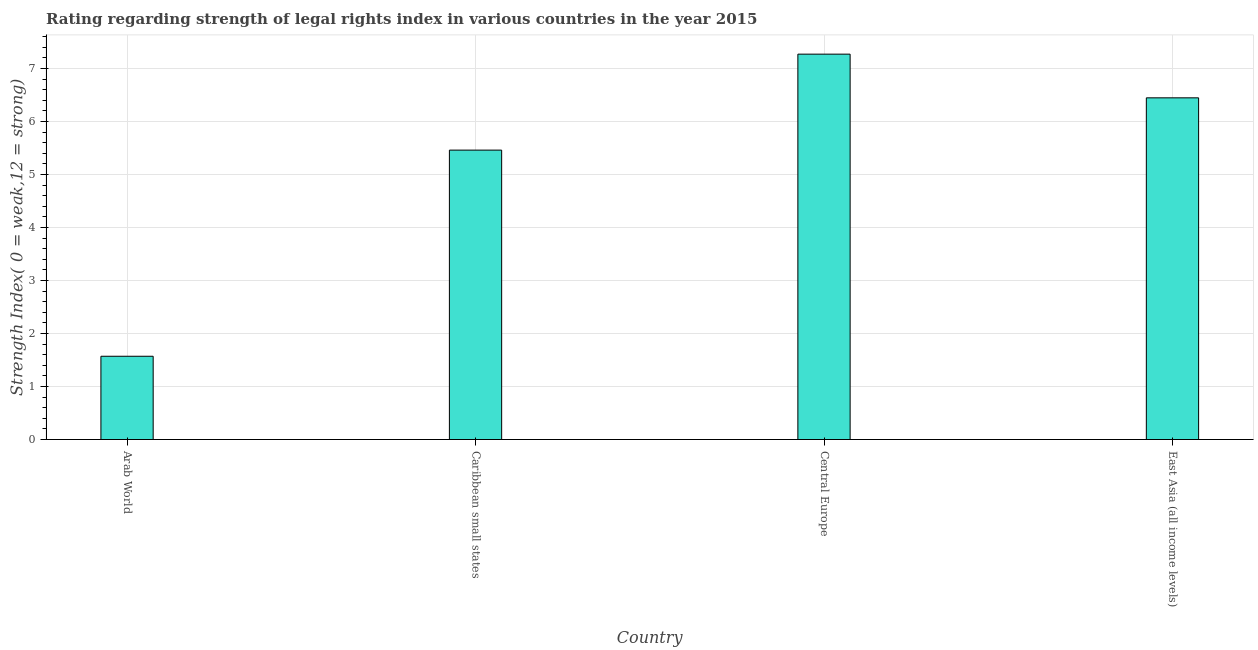Does the graph contain grids?
Your response must be concise. Yes. What is the title of the graph?
Your answer should be very brief. Rating regarding strength of legal rights index in various countries in the year 2015. What is the label or title of the X-axis?
Your answer should be compact. Country. What is the label or title of the Y-axis?
Give a very brief answer. Strength Index( 0 = weak,12 = strong). What is the strength of legal rights index in Caribbean small states?
Your response must be concise. 5.46. Across all countries, what is the maximum strength of legal rights index?
Your answer should be very brief. 7.27. Across all countries, what is the minimum strength of legal rights index?
Your answer should be compact. 1.57. In which country was the strength of legal rights index maximum?
Your answer should be compact. Central Europe. In which country was the strength of legal rights index minimum?
Provide a succinct answer. Arab World. What is the sum of the strength of legal rights index?
Your answer should be compact. 20.75. What is the difference between the strength of legal rights index in Caribbean small states and East Asia (all income levels)?
Offer a very short reply. -0.99. What is the average strength of legal rights index per country?
Your answer should be very brief. 5.19. What is the median strength of legal rights index?
Ensure brevity in your answer.  5.95. In how many countries, is the strength of legal rights index greater than 6.8 ?
Offer a very short reply. 1. What is the ratio of the strength of legal rights index in Central Europe to that in East Asia (all income levels)?
Offer a very short reply. 1.13. What is the difference between the highest and the second highest strength of legal rights index?
Offer a terse response. 0.82. Is the sum of the strength of legal rights index in Caribbean small states and East Asia (all income levels) greater than the maximum strength of legal rights index across all countries?
Ensure brevity in your answer.  Yes. Are all the bars in the graph horizontal?
Provide a short and direct response. No. How many countries are there in the graph?
Offer a very short reply. 4. What is the difference between two consecutive major ticks on the Y-axis?
Provide a succinct answer. 1. What is the Strength Index( 0 = weak,12 = strong) in Arab World?
Ensure brevity in your answer.  1.57. What is the Strength Index( 0 = weak,12 = strong) of Caribbean small states?
Your response must be concise. 5.46. What is the Strength Index( 0 = weak,12 = strong) of Central Europe?
Provide a succinct answer. 7.27. What is the Strength Index( 0 = weak,12 = strong) in East Asia (all income levels)?
Provide a succinct answer. 6.45. What is the difference between the Strength Index( 0 = weak,12 = strong) in Arab World and Caribbean small states?
Your response must be concise. -3.89. What is the difference between the Strength Index( 0 = weak,12 = strong) in Arab World and Central Europe?
Make the answer very short. -5.7. What is the difference between the Strength Index( 0 = weak,12 = strong) in Arab World and East Asia (all income levels)?
Offer a terse response. -4.88. What is the difference between the Strength Index( 0 = weak,12 = strong) in Caribbean small states and Central Europe?
Offer a very short reply. -1.81. What is the difference between the Strength Index( 0 = weak,12 = strong) in Caribbean small states and East Asia (all income levels)?
Offer a very short reply. -0.99. What is the difference between the Strength Index( 0 = weak,12 = strong) in Central Europe and East Asia (all income levels)?
Provide a short and direct response. 0.82. What is the ratio of the Strength Index( 0 = weak,12 = strong) in Arab World to that in Caribbean small states?
Your answer should be compact. 0.29. What is the ratio of the Strength Index( 0 = weak,12 = strong) in Arab World to that in Central Europe?
Make the answer very short. 0.22. What is the ratio of the Strength Index( 0 = weak,12 = strong) in Arab World to that in East Asia (all income levels)?
Make the answer very short. 0.24. What is the ratio of the Strength Index( 0 = weak,12 = strong) in Caribbean small states to that in Central Europe?
Keep it short and to the point. 0.75. What is the ratio of the Strength Index( 0 = weak,12 = strong) in Caribbean small states to that in East Asia (all income levels)?
Offer a very short reply. 0.85. What is the ratio of the Strength Index( 0 = weak,12 = strong) in Central Europe to that in East Asia (all income levels)?
Keep it short and to the point. 1.13. 